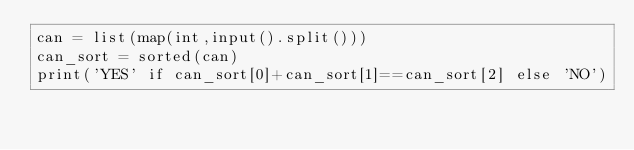Convert code to text. <code><loc_0><loc_0><loc_500><loc_500><_Python_>can = list(map(int,input().split()))
can_sort = sorted(can)
print('YES' if can_sort[0]+can_sort[1]==can_sort[2] else 'NO')</code> 